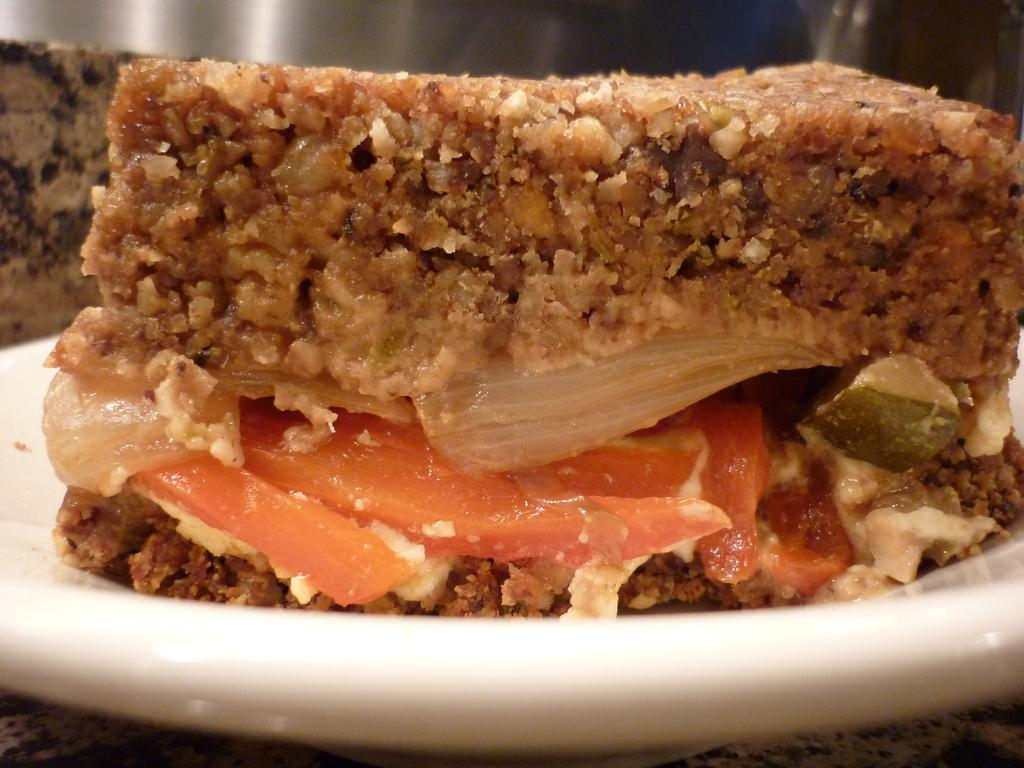What is the main subject of the image? The main subject of the image is a food item served in a plate. Can you describe the food item in the plate? Unfortunately, the specific food item cannot be determined from the given facts. What is the purpose of the plate in the image? The plate is used to serve the food item in the image. How many cars can be seen parked near the food item in the image? There is no mention of cars in the image, so it cannot be determined if any are present. 